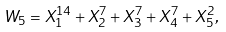Convert formula to latex. <formula><loc_0><loc_0><loc_500><loc_500>W _ { 5 } = X _ { 1 } ^ { 1 4 } + X _ { 2 } ^ { 7 } + X _ { 3 } ^ { 7 } + X _ { 4 } ^ { 7 } + X _ { 5 } ^ { 2 } ,</formula> 